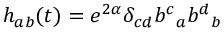<formula> <loc_0><loc_0><loc_500><loc_500>h _ { a b } ( t ) = e ^ { 2 \alpha } \delta _ { c d } { b ^ { c } } _ { a } { b ^ { d } } _ { b }</formula> 